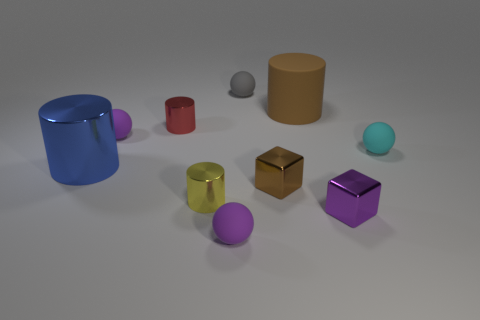Subtract 1 cylinders. How many cylinders are left? 3 Subtract all spheres. How many objects are left? 6 Subtract 0 blue blocks. How many objects are left? 10 Subtract all large red cylinders. Subtract all small purple cubes. How many objects are left? 9 Add 2 gray balls. How many gray balls are left? 3 Add 8 small brown metal blocks. How many small brown metal blocks exist? 9 